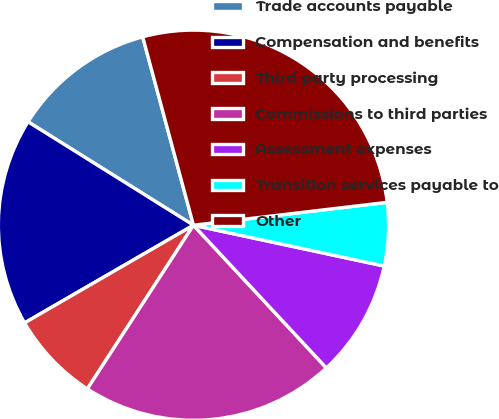Convert chart to OTSL. <chart><loc_0><loc_0><loc_500><loc_500><pie_chart><fcel>Trade accounts payable<fcel>Compensation and benefits<fcel>Third party processing<fcel>Commissions to third parties<fcel>Assessment expenses<fcel>Transition services payable to<fcel>Other<nl><fcel>11.92%<fcel>17.24%<fcel>7.5%<fcel>21.09%<fcel>9.71%<fcel>5.23%<fcel>27.32%<nl></chart> 